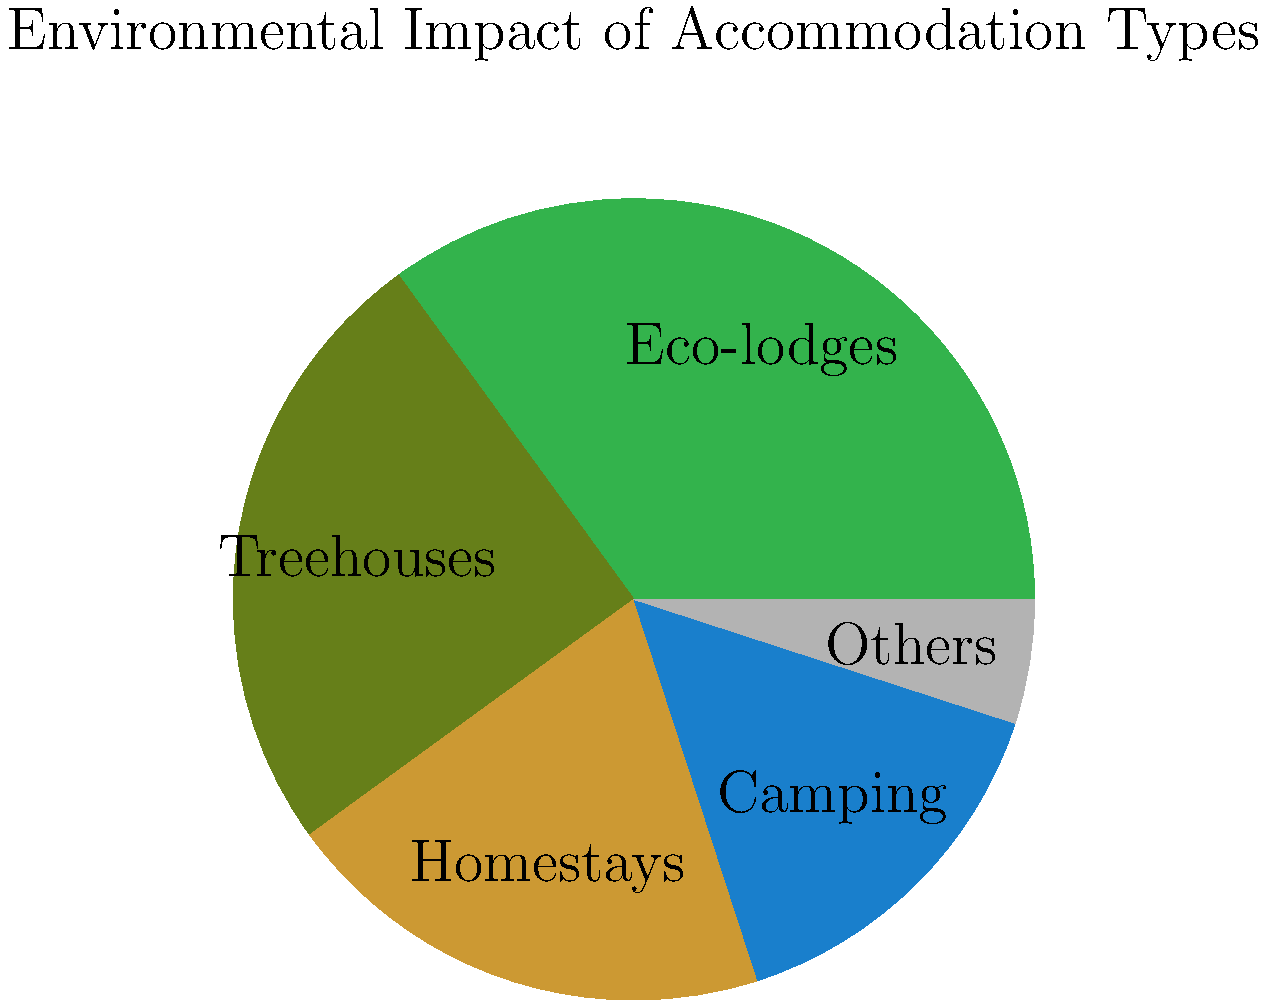As an eco-tourism enthusiast interested in historical destinations, you come across a study on the environmental impact of various accommodation types in popular eco-tourism locations. The pie chart above shows the distribution of environmental impact across different accommodation options. Which type of accommodation has the second-largest environmental impact, and what percentage does it represent? To answer this question, we need to analyze the pie chart and follow these steps:

1. Identify all accommodation types and their corresponding percentages:
   - Eco-lodges: 35%
   - Treehouses: 25%
   - Homestays: 20%
   - Camping: 15%
   - Others: 5%

2. Order the accommodation types from largest to smallest environmental impact:
   1. Eco-lodges (35%)
   2. Treehouses (25%)
   3. Homestays (20%)
   4. Camping (15%)
   5. Others (5%)

3. Identify the second-largest environmental impact:
   The second-largest slice of the pie chart represents Treehouses at 25%.

Therefore, the accommodation type with the second-largest environmental impact is Treehouses, representing 25% of the total environmental impact among the given options.
Answer: Treehouses, 25% 